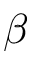<formula> <loc_0><loc_0><loc_500><loc_500>\beta</formula> 